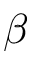<formula> <loc_0><loc_0><loc_500><loc_500>\beta</formula> 